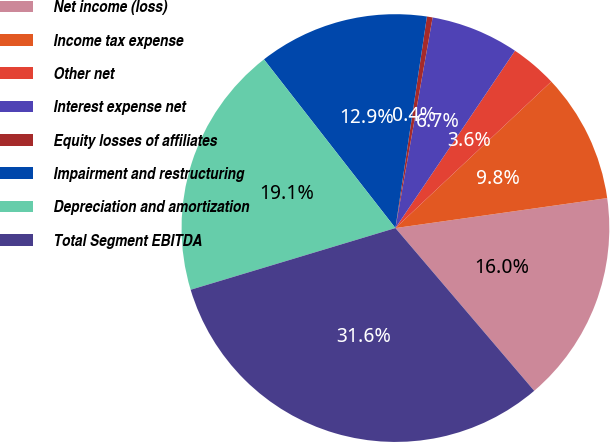<chart> <loc_0><loc_0><loc_500><loc_500><pie_chart><fcel>Net income (loss)<fcel>Income tax expense<fcel>Other net<fcel>Interest expense net<fcel>Equity losses of affiliates<fcel>Impairment and restructuring<fcel>Depreciation and amortization<fcel>Total Segment EBITDA<nl><fcel>16.0%<fcel>9.77%<fcel>3.55%<fcel>6.66%<fcel>0.43%<fcel>12.89%<fcel>19.12%<fcel>31.58%<nl></chart> 